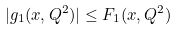<formula> <loc_0><loc_0><loc_500><loc_500>| g _ { 1 } ( x , Q ^ { 2 } ) | \leq F _ { 1 } ( x , Q ^ { 2 } )</formula> 